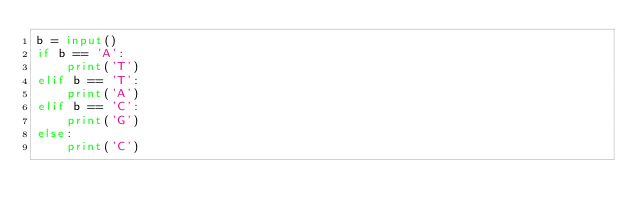Convert code to text. <code><loc_0><loc_0><loc_500><loc_500><_Python_>b = input()
if b == 'A':
    print('T')
elif b == 'T':
    print('A')
elif b == 'C':
    print('G')
else:
    print('C')</code> 